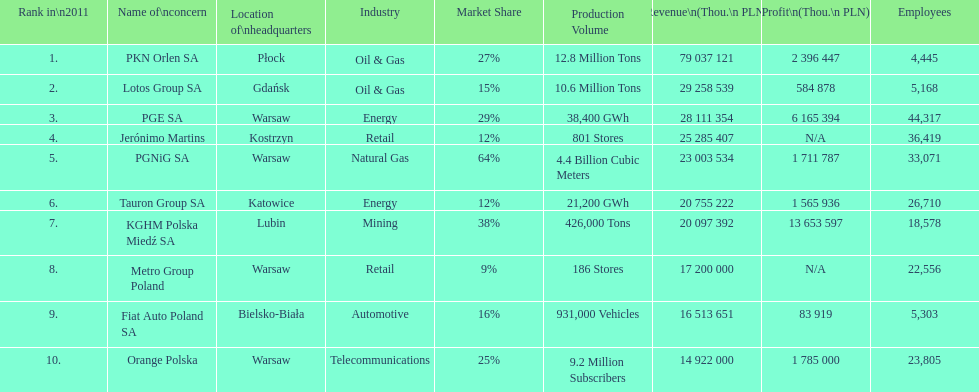Which company had the least revenue? Orange Polska. 